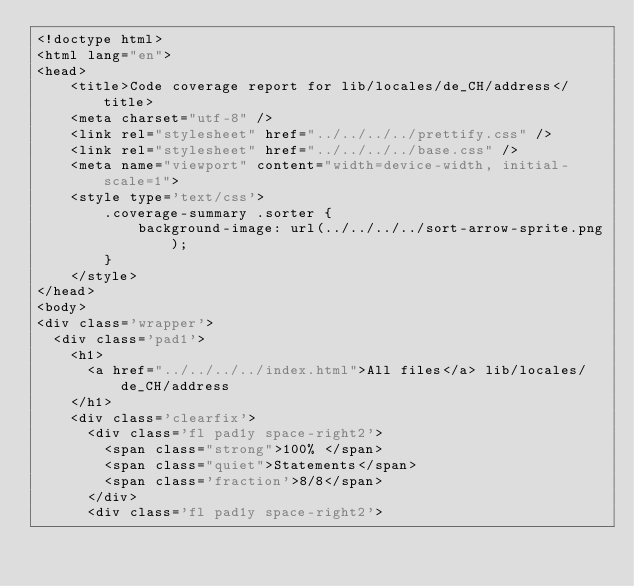<code> <loc_0><loc_0><loc_500><loc_500><_HTML_><!doctype html>
<html lang="en">
<head>
    <title>Code coverage report for lib/locales/de_CH/address</title>
    <meta charset="utf-8" />
    <link rel="stylesheet" href="../../../../prettify.css" />
    <link rel="stylesheet" href="../../../../base.css" />
    <meta name="viewport" content="width=device-width, initial-scale=1">
    <style type='text/css'>
        .coverage-summary .sorter {
            background-image: url(../../../../sort-arrow-sprite.png);
        }
    </style>
</head>
<body>
<div class='wrapper'>
  <div class='pad1'>
    <h1>
      <a href="../../../../index.html">All files</a> lib/locales/de_CH/address
    </h1>
    <div class='clearfix'>
      <div class='fl pad1y space-right2'>
        <span class="strong">100% </span>
        <span class="quiet">Statements</span>
        <span class='fraction'>8/8</span>
      </div>
      <div class='fl pad1y space-right2'></code> 